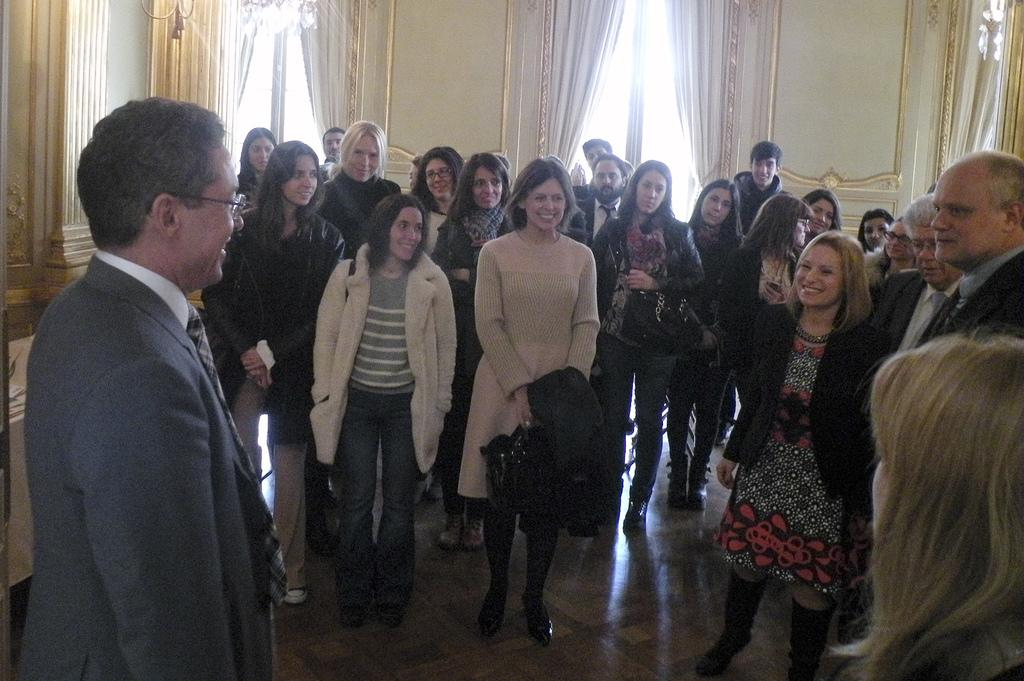How many people are in the image? There is a group of people in the image, but the exact number is not specified. What are the people doing in the image? The people are standing on the floor. What can be seen in the background of the image? There are curtains and windows in the background of the image. Can you tell me what type of hobbies the people in the image are discussing? There is no information about the people's hobbies or any conversation taking place in the image. 